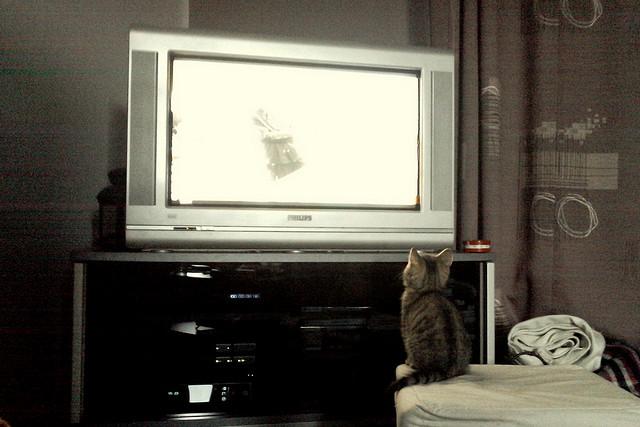Are these curtains similar in color to burlap?
Concise answer only. Yes. Why would people have curtains on the window?
Write a very short answer. Privacy. What is the cat doing?
Give a very brief answer. Watching tv. 